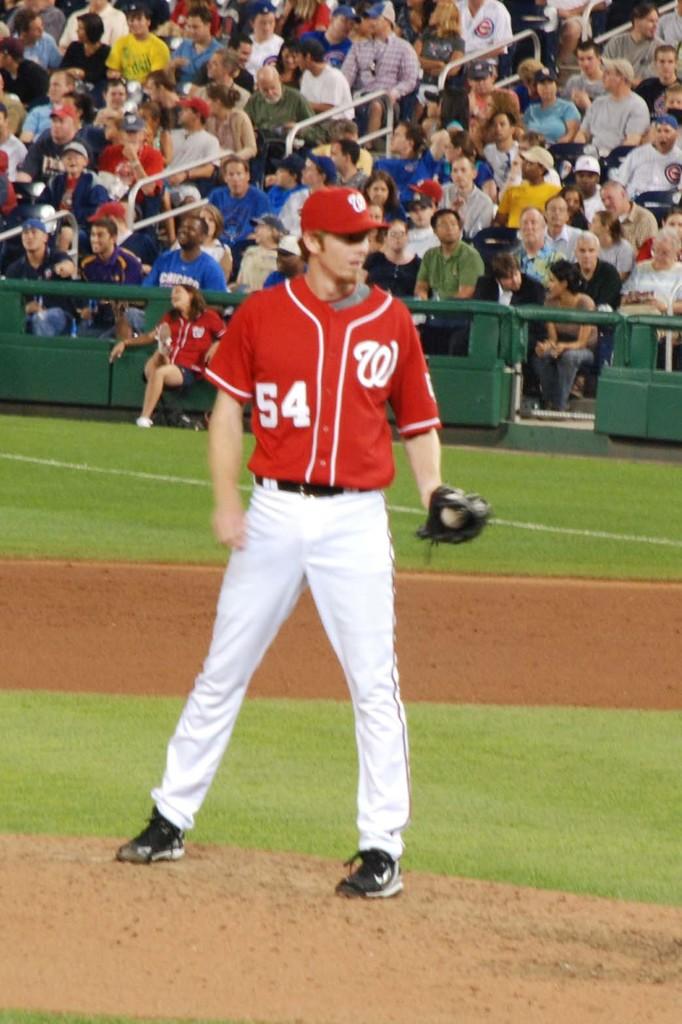What is the player's jersey numbe?
Keep it short and to the point. 54. 